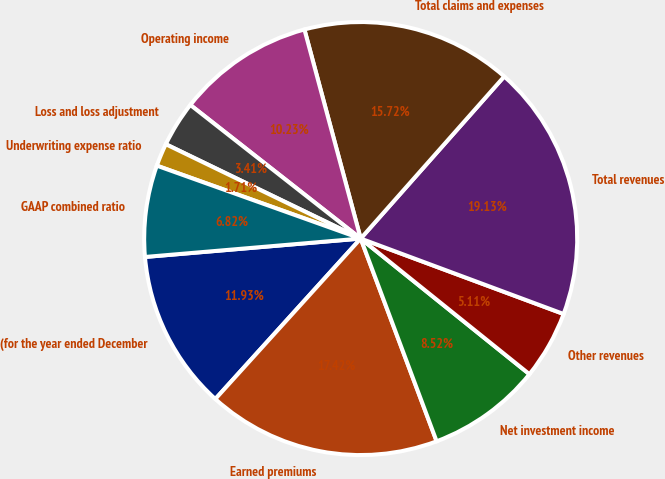Convert chart to OTSL. <chart><loc_0><loc_0><loc_500><loc_500><pie_chart><fcel>(for the year ended December<fcel>Earned premiums<fcel>Net investment income<fcel>Other revenues<fcel>Total revenues<fcel>Total claims and expenses<fcel>Operating income<fcel>Loss and loss adjustment<fcel>Underwriting expense ratio<fcel>GAAP combined ratio<nl><fcel>11.93%<fcel>17.42%<fcel>8.52%<fcel>5.11%<fcel>19.13%<fcel>15.72%<fcel>10.23%<fcel>3.41%<fcel>1.71%<fcel>6.82%<nl></chart> 